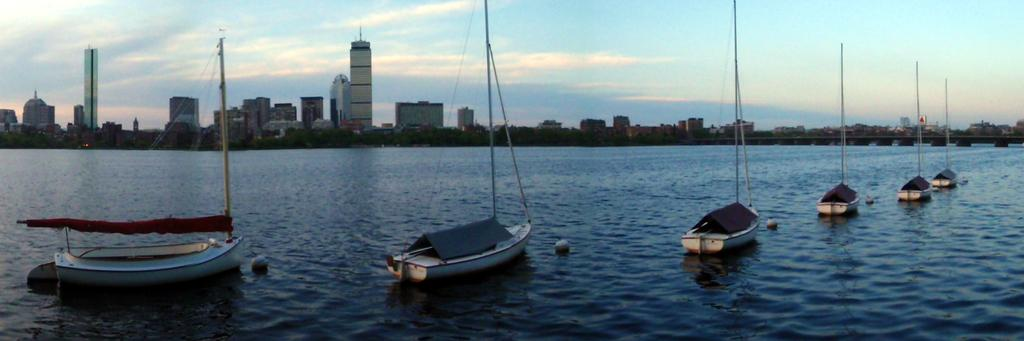What type of vehicles are present in the image? There are boats in the image. What features do the boats have? The boats have poles and ropes. Where are the boats located? The boats are in a large water body. What structures can be seen in the image? There is a bridge and a group of buildings visible in the image. How would you describe the weather in the image? The sky is cloudy in the image. What letter is being used to write the history of the boats in the image? There is no letter or writing present in the image, and no history of the boats is being documented. 